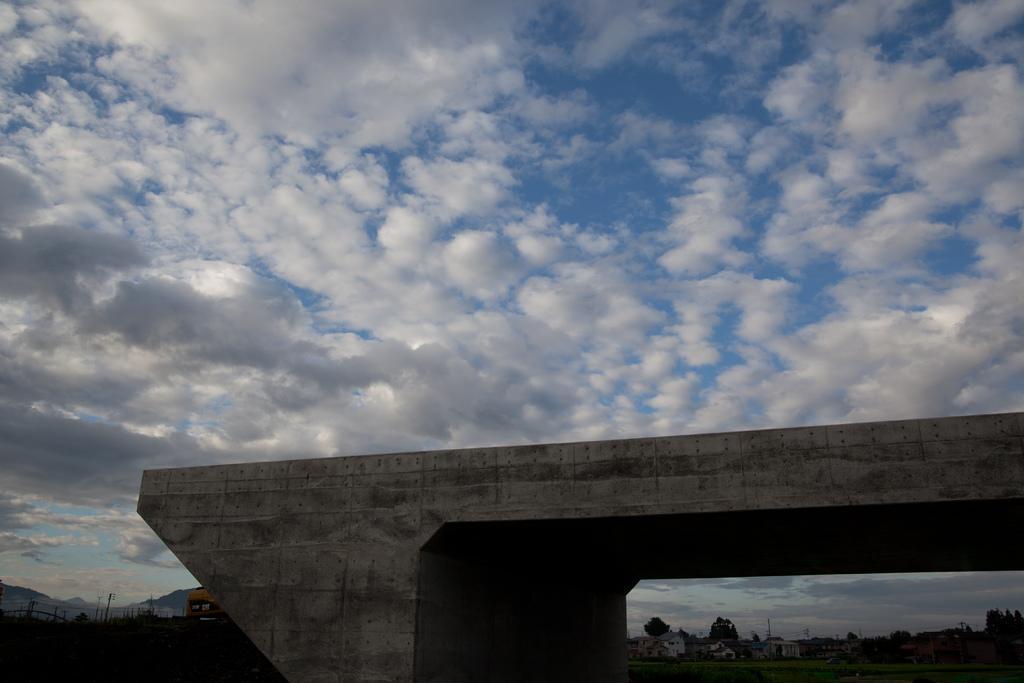Describe this image in one or two sentences. In this image I can see clouds and the sky. In the background I can see number of trees and buildings. 